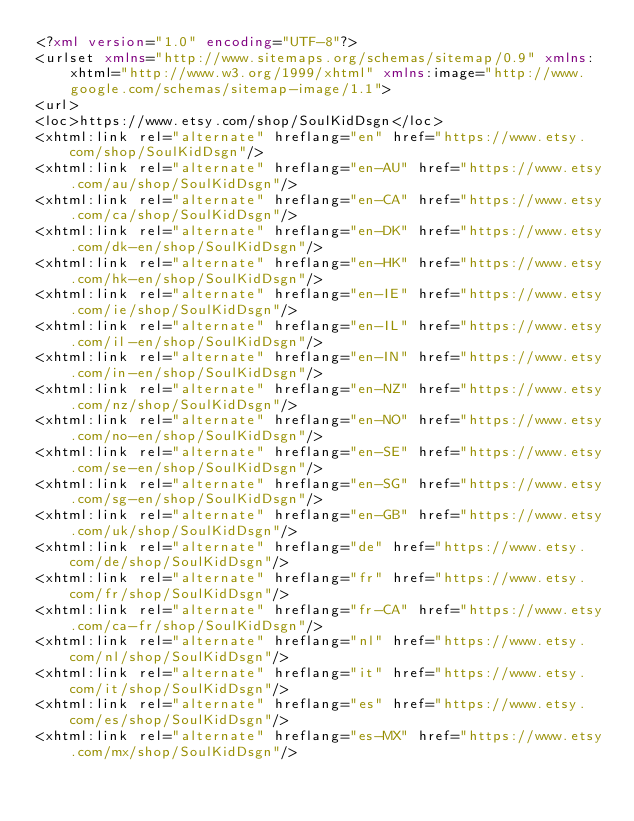<code> <loc_0><loc_0><loc_500><loc_500><_XML_><?xml version="1.0" encoding="UTF-8"?>
<urlset xmlns="http://www.sitemaps.org/schemas/sitemap/0.9" xmlns:xhtml="http://www.w3.org/1999/xhtml" xmlns:image="http://www.google.com/schemas/sitemap-image/1.1">
<url>
<loc>https://www.etsy.com/shop/SoulKidDsgn</loc>
<xhtml:link rel="alternate" hreflang="en" href="https://www.etsy.com/shop/SoulKidDsgn"/>
<xhtml:link rel="alternate" hreflang="en-AU" href="https://www.etsy.com/au/shop/SoulKidDsgn"/>
<xhtml:link rel="alternate" hreflang="en-CA" href="https://www.etsy.com/ca/shop/SoulKidDsgn"/>
<xhtml:link rel="alternate" hreflang="en-DK" href="https://www.etsy.com/dk-en/shop/SoulKidDsgn"/>
<xhtml:link rel="alternate" hreflang="en-HK" href="https://www.etsy.com/hk-en/shop/SoulKidDsgn"/>
<xhtml:link rel="alternate" hreflang="en-IE" href="https://www.etsy.com/ie/shop/SoulKidDsgn"/>
<xhtml:link rel="alternate" hreflang="en-IL" href="https://www.etsy.com/il-en/shop/SoulKidDsgn"/>
<xhtml:link rel="alternate" hreflang="en-IN" href="https://www.etsy.com/in-en/shop/SoulKidDsgn"/>
<xhtml:link rel="alternate" hreflang="en-NZ" href="https://www.etsy.com/nz/shop/SoulKidDsgn"/>
<xhtml:link rel="alternate" hreflang="en-NO" href="https://www.etsy.com/no-en/shop/SoulKidDsgn"/>
<xhtml:link rel="alternate" hreflang="en-SE" href="https://www.etsy.com/se-en/shop/SoulKidDsgn"/>
<xhtml:link rel="alternate" hreflang="en-SG" href="https://www.etsy.com/sg-en/shop/SoulKidDsgn"/>
<xhtml:link rel="alternate" hreflang="en-GB" href="https://www.etsy.com/uk/shop/SoulKidDsgn"/>
<xhtml:link rel="alternate" hreflang="de" href="https://www.etsy.com/de/shop/SoulKidDsgn"/>
<xhtml:link rel="alternate" hreflang="fr" href="https://www.etsy.com/fr/shop/SoulKidDsgn"/>
<xhtml:link rel="alternate" hreflang="fr-CA" href="https://www.etsy.com/ca-fr/shop/SoulKidDsgn"/>
<xhtml:link rel="alternate" hreflang="nl" href="https://www.etsy.com/nl/shop/SoulKidDsgn"/>
<xhtml:link rel="alternate" hreflang="it" href="https://www.etsy.com/it/shop/SoulKidDsgn"/>
<xhtml:link rel="alternate" hreflang="es" href="https://www.etsy.com/es/shop/SoulKidDsgn"/>
<xhtml:link rel="alternate" hreflang="es-MX" href="https://www.etsy.com/mx/shop/SoulKidDsgn"/></code> 